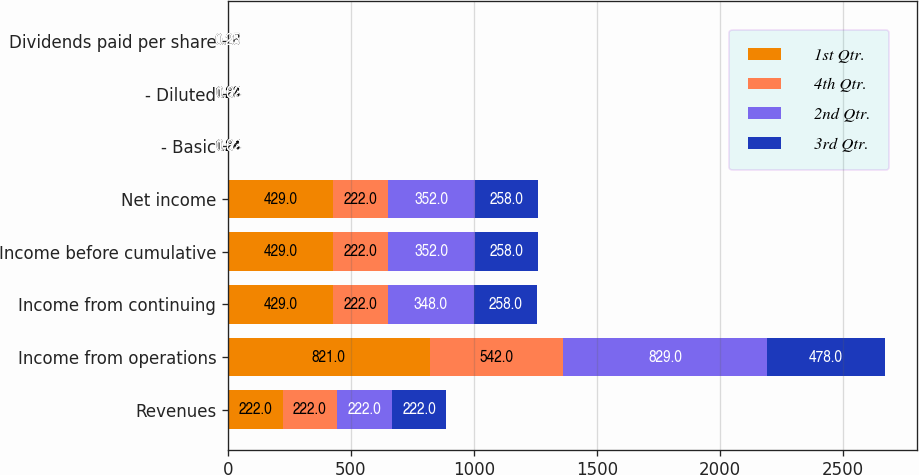Convert chart to OTSL. <chart><loc_0><loc_0><loc_500><loc_500><stacked_bar_chart><ecel><fcel>Revenues<fcel>Income from operations<fcel>Income from continuing<fcel>Income before cumulative<fcel>Net income<fcel>- Basic<fcel>- Diluted<fcel>Dividends paid per share<nl><fcel>1st Qtr.<fcel>222<fcel>821<fcel>429<fcel>429<fcel>429<fcel>1.24<fcel>1.23<fcel>0.28<nl><fcel>4th Qtr.<fcel>222<fcel>542<fcel>222<fcel>222<fcel>222<fcel>0.64<fcel>0.64<fcel>0.25<nl><fcel>2nd Qtr.<fcel>222<fcel>829<fcel>348<fcel>352<fcel>352<fcel>1.02<fcel>1.02<fcel>0.25<nl><fcel>3rd Qtr.<fcel>222<fcel>478<fcel>258<fcel>258<fcel>258<fcel>0.83<fcel>0.83<fcel>0.25<nl></chart> 